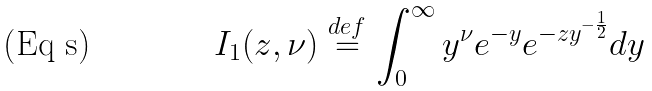<formula> <loc_0><loc_0><loc_500><loc_500>I _ { 1 } ( z , \nu ) \stackrel { d e f } { = } \int _ { 0 } ^ { \infty } y ^ { \nu } e ^ { - y } e ^ { - z y ^ { - \frac { 1 } { 2 } } } d y</formula> 